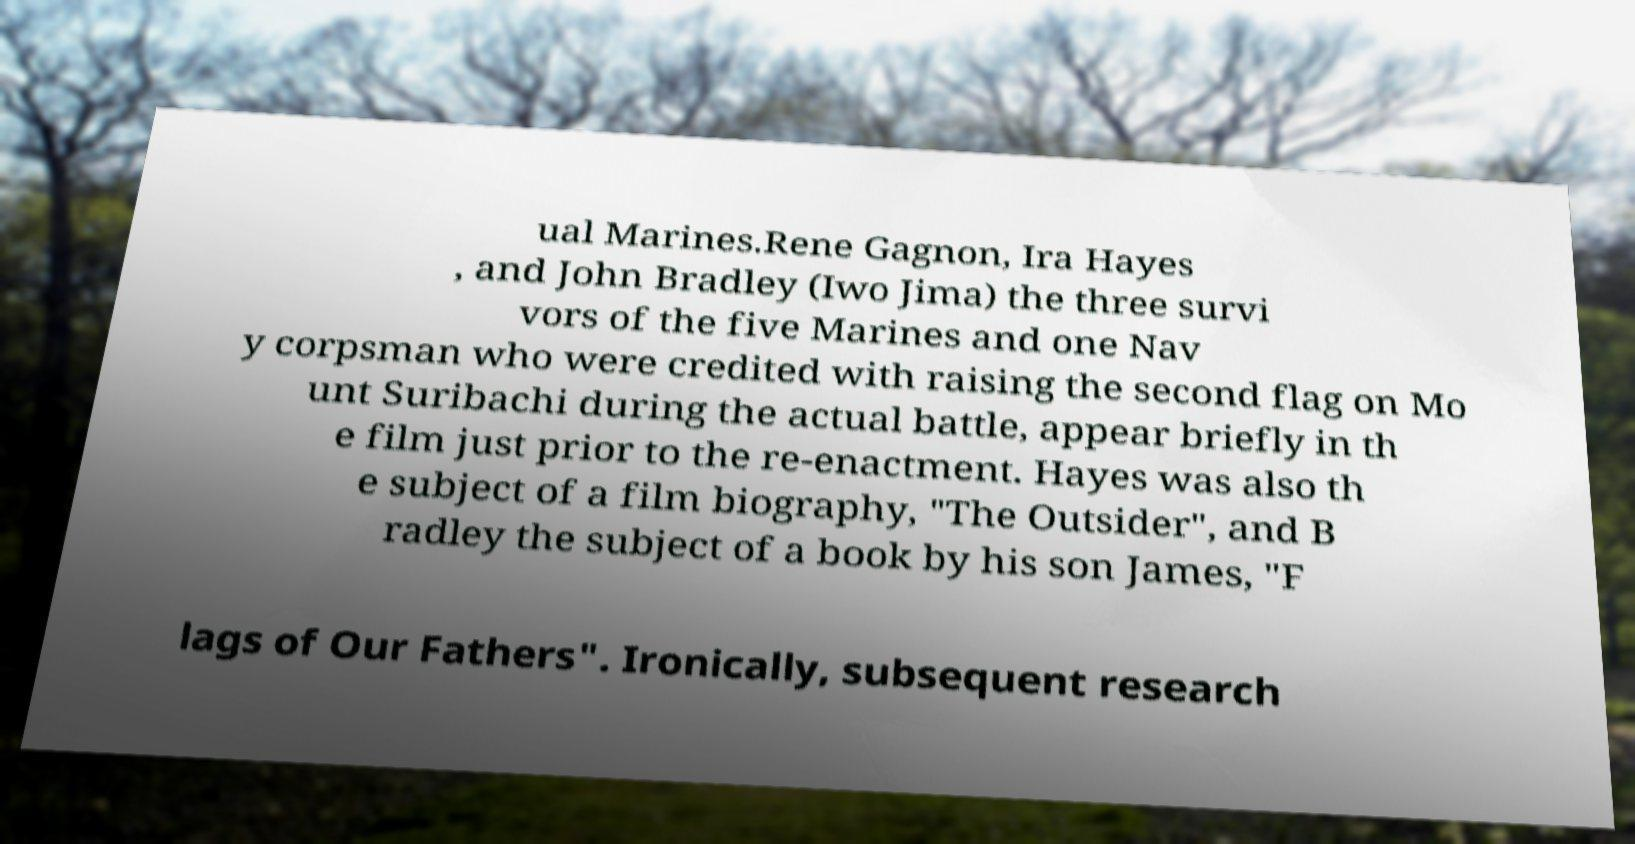Can you read and provide the text displayed in the image?This photo seems to have some interesting text. Can you extract and type it out for me? ual Marines.Rene Gagnon, Ira Hayes , and John Bradley (Iwo Jima) the three survi vors of the five Marines and one Nav y corpsman who were credited with raising the second flag on Mo unt Suribachi during the actual battle, appear briefly in th e film just prior to the re-enactment. Hayes was also th e subject of a film biography, "The Outsider", and B radley the subject of a book by his son James, "F lags of Our Fathers". Ironically, subsequent research 